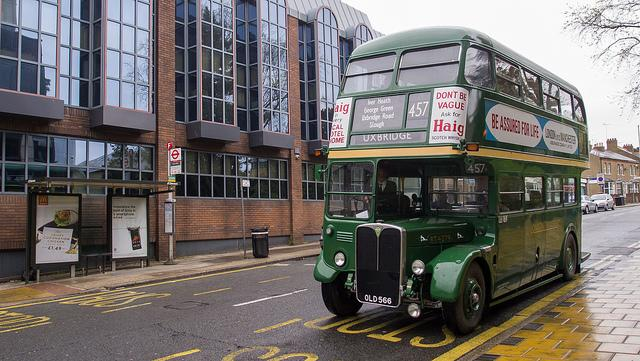What type of infrastructure does this city avoid having? subway 